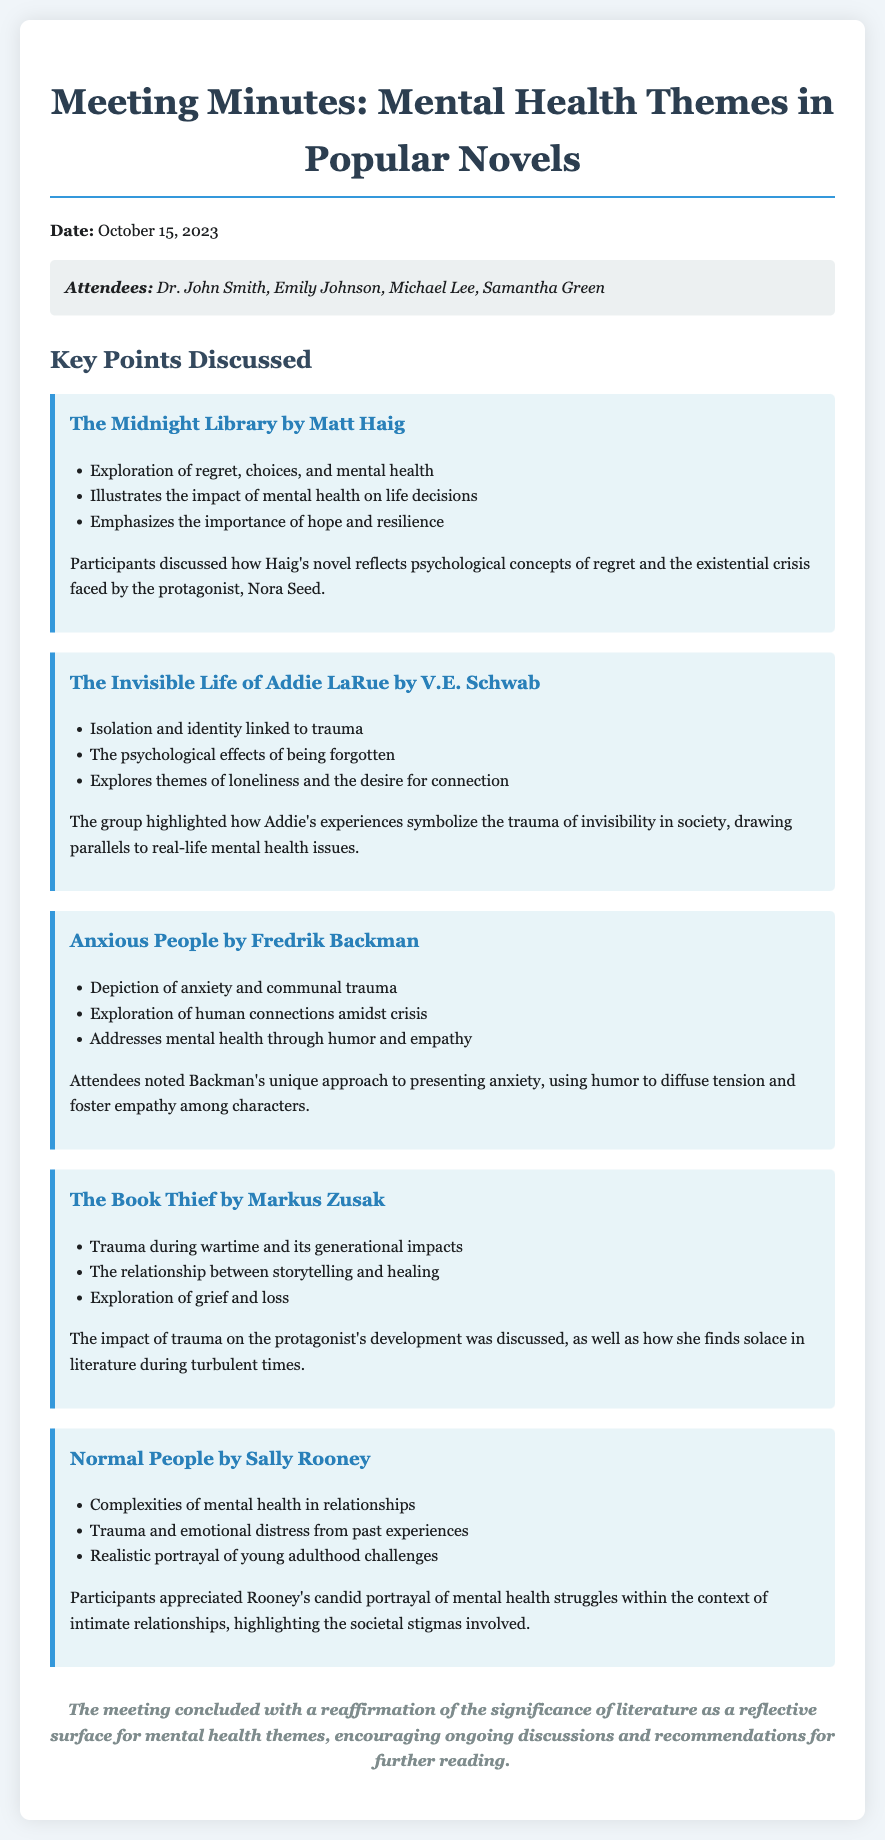What is the date of the meeting? The meeting date is mentioned prominently in the document, listed as October 15, 2023.
Answer: October 15, 2023 Who is the author of "The Midnight Library"? The author of "The Midnight Library" is specified in the document as Matt Haig.
Answer: Matt Haig What theme is explored in "The Invisible Life of Addie LaRue"? The document highlights isolation and identity as a key theme in "The Invisible Life of Addie LaRue".
Answer: Isolation and identity Which author wrote "Normal People"? The document states that "Normal People" is written by Sally Rooney.
Answer: Sally Rooney What mental health aspect is depicted in "Anxious People"? The document describes anxiety as a central mental health aspect depicted in "Anxious People".
Answer: Anxiety How does "The Book Thief" address trauma? The document explains that "The Book Thief" addresses trauma during wartime and its generational impacts.
Answer: Trauma during wartime What is the overall conclusion of the meeting? The conclusion indicates that literature serves as a reflective surface for mental health themes, encouraging ongoing discussions.
Answer: Literature as a reflective surface Who attended the meeting? The attendees are listed as Dr. John Smith, Emily Johnson, Michael Lee, and Samantha Green.
Answer: Dr. John Smith, Emily Johnson, Michael Lee, Samantha Green 